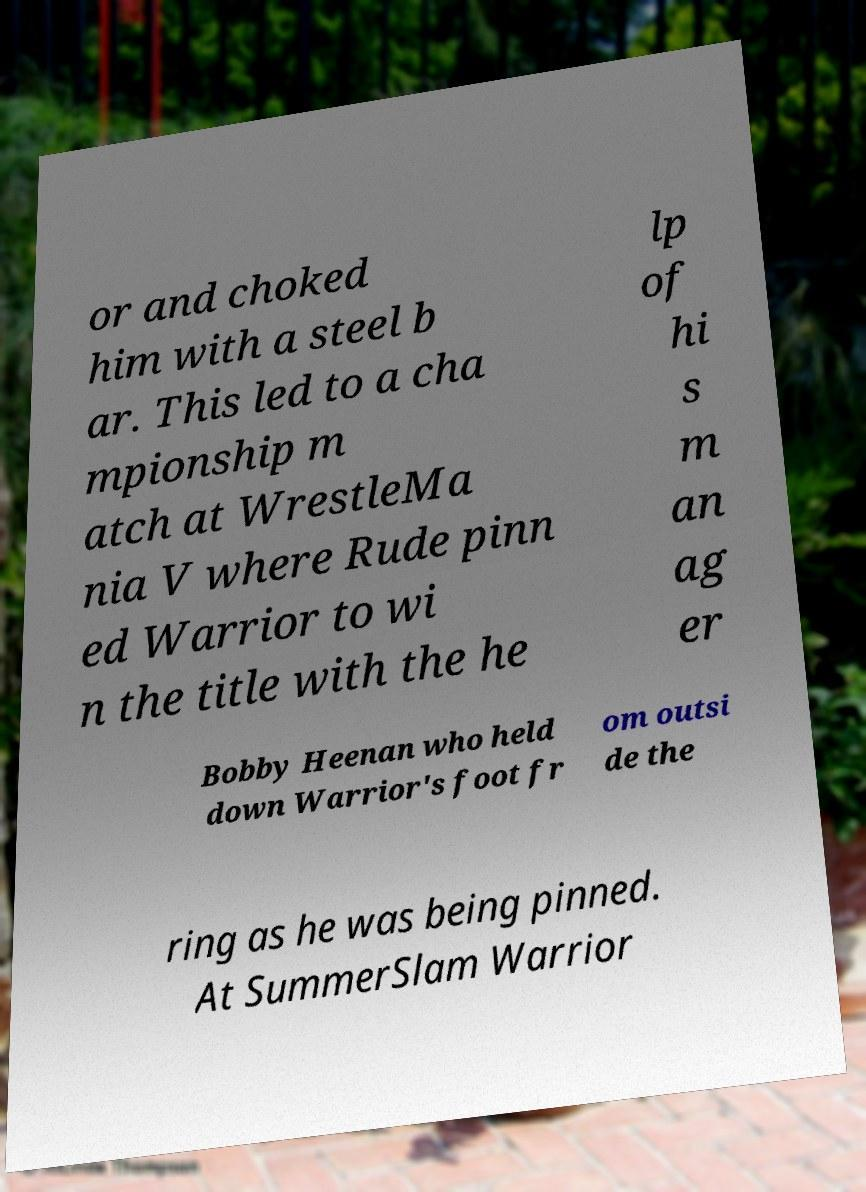What messages or text are displayed in this image? I need them in a readable, typed format. or and choked him with a steel b ar. This led to a cha mpionship m atch at WrestleMa nia V where Rude pinn ed Warrior to wi n the title with the he lp of hi s m an ag er Bobby Heenan who held down Warrior's foot fr om outsi de the ring as he was being pinned. At SummerSlam Warrior 